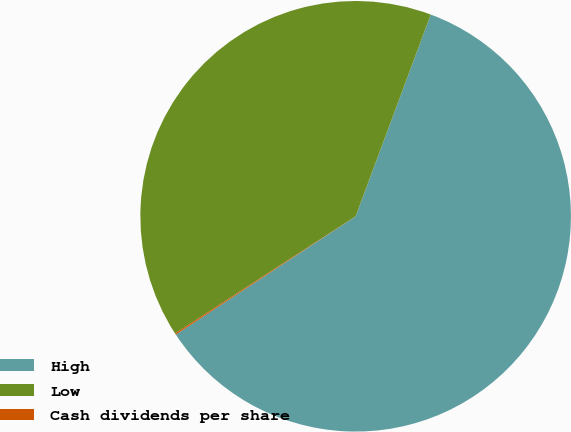<chart> <loc_0><loc_0><loc_500><loc_500><pie_chart><fcel>High<fcel>Low<fcel>Cash dividends per share<nl><fcel>60.07%<fcel>39.84%<fcel>0.1%<nl></chart> 